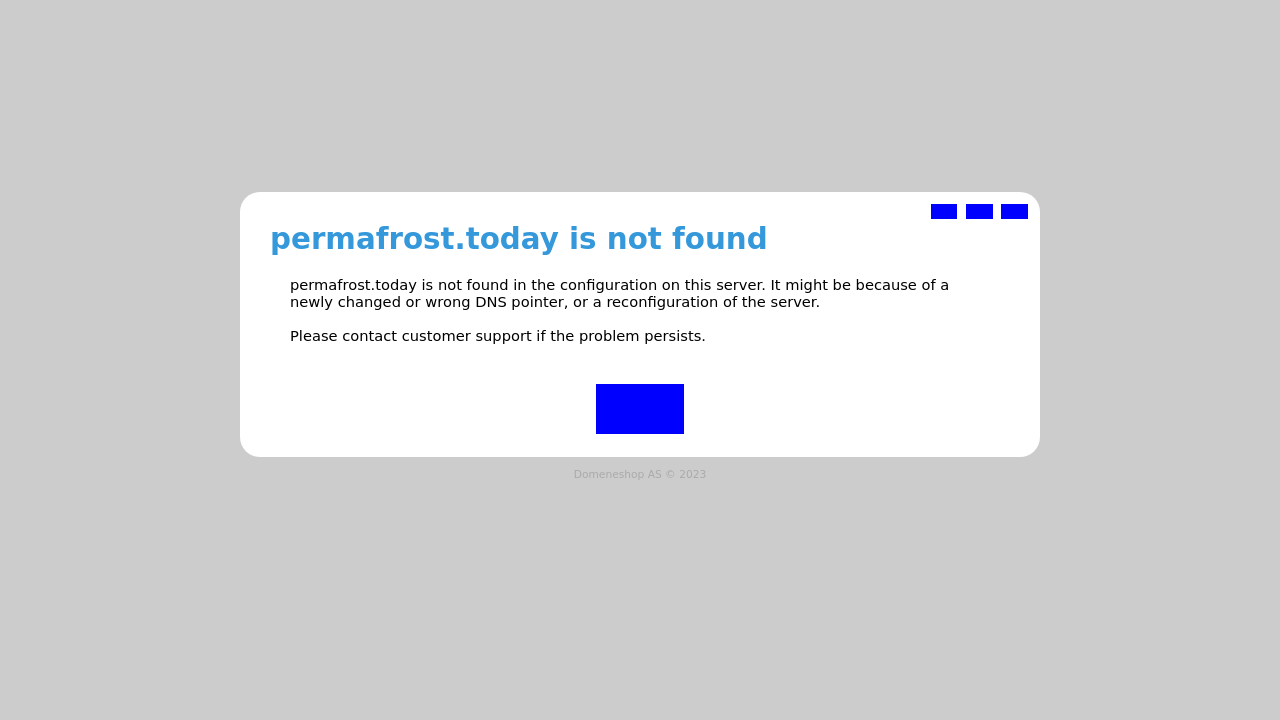What are some key considerations for designing error pages like the one shown in this image, to enhance user experience? Designing effective error pages should focus on clarity, helpfulness, and maintaining the design consistency of the site. Provide a clear message on what went wrong and why. Offer solutions or alternatives, such as links back to the homepage, search functions, or customer support contact information. Additionally, maintain visual appeal by aligning the design with the rest of the site's aesthetic. Lastly, ensure that the error page is responsive and looks good on all devices to keep user experience positive even in error scenarios. 